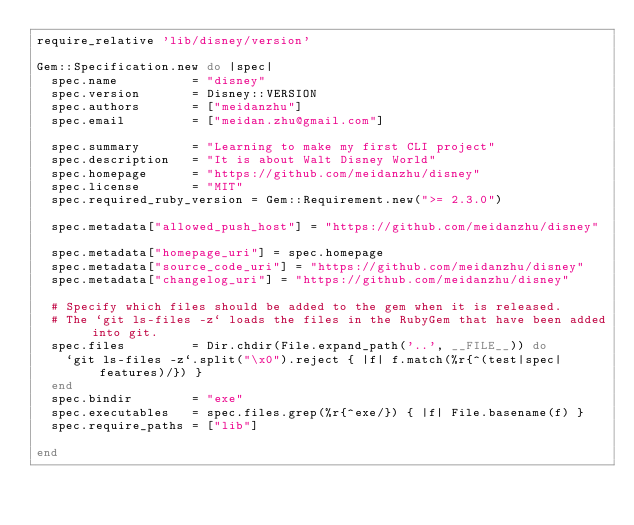<code> <loc_0><loc_0><loc_500><loc_500><_Ruby_>require_relative 'lib/disney/version'

Gem::Specification.new do |spec|
  spec.name          = "disney"
  spec.version       = Disney::VERSION
  spec.authors       = ["meidanzhu"]
  spec.email         = ["meidan.zhu@gmail.com"]

  spec.summary       = "Learning to make my first CLI project"
  spec.description   = "It is about Walt Disney World"
  spec.homepage      = "https://github.com/meidanzhu/disney"
  spec.license       = "MIT"
  spec.required_ruby_version = Gem::Requirement.new(">= 2.3.0")

  spec.metadata["allowed_push_host"] = "https://github.com/meidanzhu/disney"

  spec.metadata["homepage_uri"] = spec.homepage
  spec.metadata["source_code_uri"] = "https://github.com/meidanzhu/disney"
  spec.metadata["changelog_uri"] = "https://github.com/meidanzhu/disney"

  # Specify which files should be added to the gem when it is released.
  # The `git ls-files -z` loads the files in the RubyGem that have been added into git.
  spec.files         = Dir.chdir(File.expand_path('..', __FILE__)) do
    `git ls-files -z`.split("\x0").reject { |f| f.match(%r{^(test|spec|features)/}) }
  end
  spec.bindir        = "exe"
  spec.executables   = spec.files.grep(%r{^exe/}) { |f| File.basename(f) }
  spec.require_paths = ["lib"]

end
</code> 